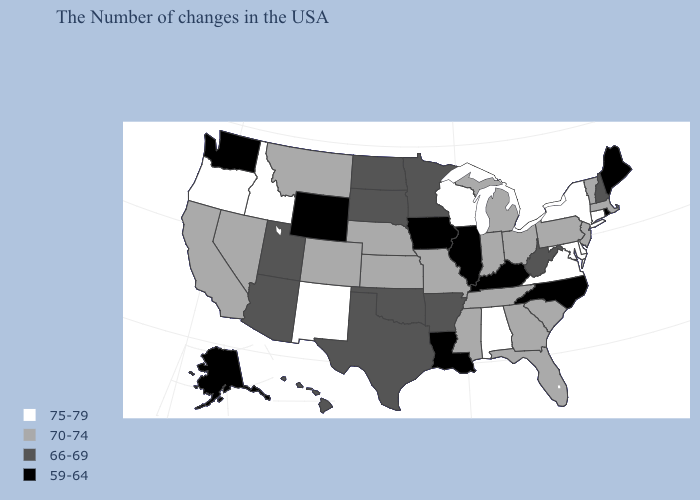What is the value of Alabama?
Short answer required. 75-79. What is the value of Illinois?
Quick response, please. 59-64. Which states hav the highest value in the South?
Write a very short answer. Delaware, Maryland, Virginia, Alabama. How many symbols are there in the legend?
Answer briefly. 4. Name the states that have a value in the range 75-79?
Concise answer only. Connecticut, New York, Delaware, Maryland, Virginia, Alabama, Wisconsin, New Mexico, Idaho, Oregon. Among the states that border Nevada , which have the highest value?
Concise answer only. Idaho, Oregon. What is the value of Massachusetts?
Quick response, please. 70-74. What is the lowest value in states that border Oregon?
Write a very short answer. 59-64. What is the lowest value in the MidWest?
Short answer required. 59-64. Among the states that border New Mexico , does Utah have the highest value?
Give a very brief answer. No. Name the states that have a value in the range 70-74?
Short answer required. Massachusetts, Vermont, New Jersey, Pennsylvania, South Carolina, Ohio, Florida, Georgia, Michigan, Indiana, Tennessee, Mississippi, Missouri, Kansas, Nebraska, Colorado, Montana, Nevada, California. What is the lowest value in the Northeast?
Answer briefly. 59-64. What is the value of Tennessee?
Write a very short answer. 70-74. Among the states that border Nebraska , does South Dakota have the lowest value?
Answer briefly. No. Name the states that have a value in the range 66-69?
Short answer required. New Hampshire, West Virginia, Arkansas, Minnesota, Oklahoma, Texas, South Dakota, North Dakota, Utah, Arizona, Hawaii. 